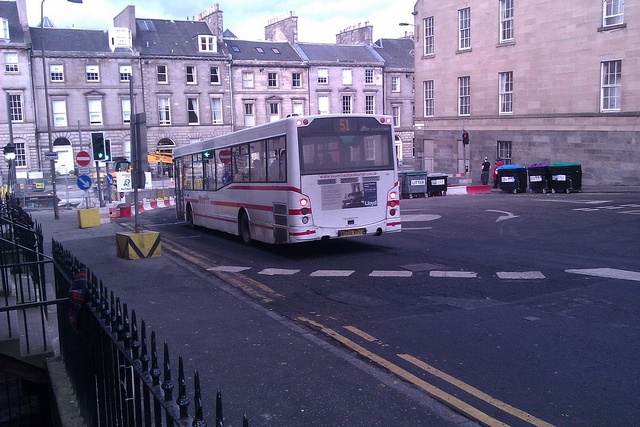Describe the objects in this image and their specific colors. I can see bus in lavender, purple, and gray tones, traffic light in lavender, navy, black, and darkgray tones, people in lavender, navy, black, and purple tones, people in lavender, purple, and black tones, and traffic light in lavender, navy, black, purple, and lightblue tones in this image. 